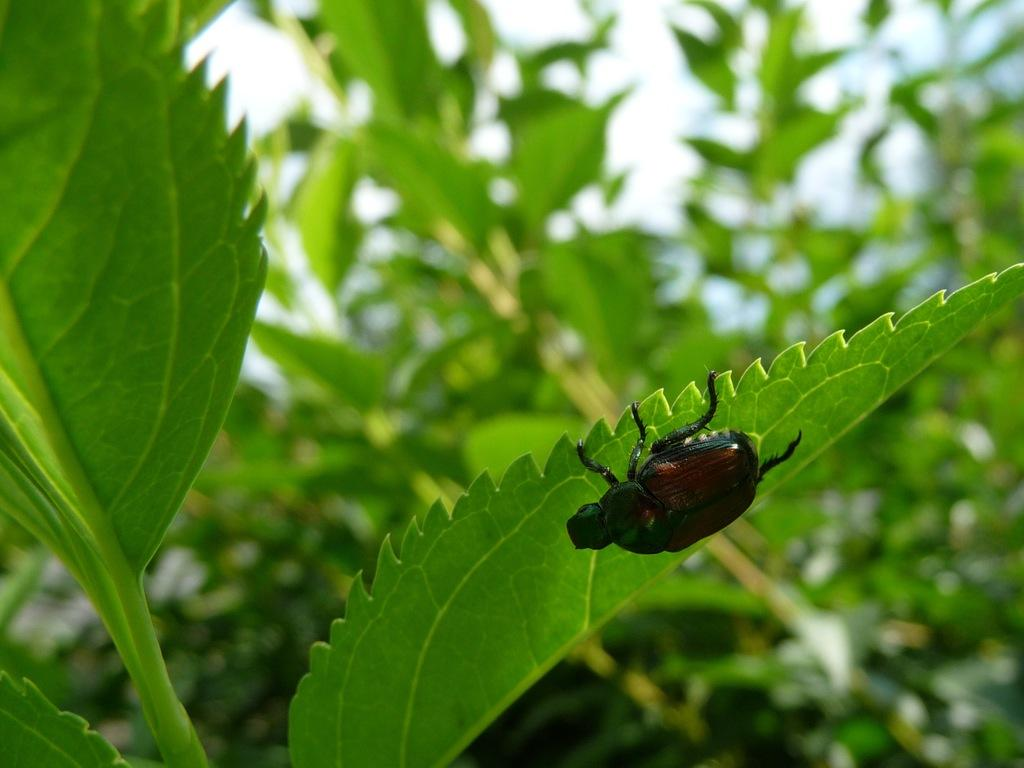What can be seen in the foreground of the picture? There are leaves in the foreground of the picture. What is the main subject of the image? There is an insect on a leaf in the center of the image. What type of environment is depicted in the background of the image? There is greenery in the background of the image. Who is the owner of the knife in the image? There is no knife present in the image. What type of quilt is draped over the insect in the image? There is no quilt present in the image; it is an insect on a leaf. 